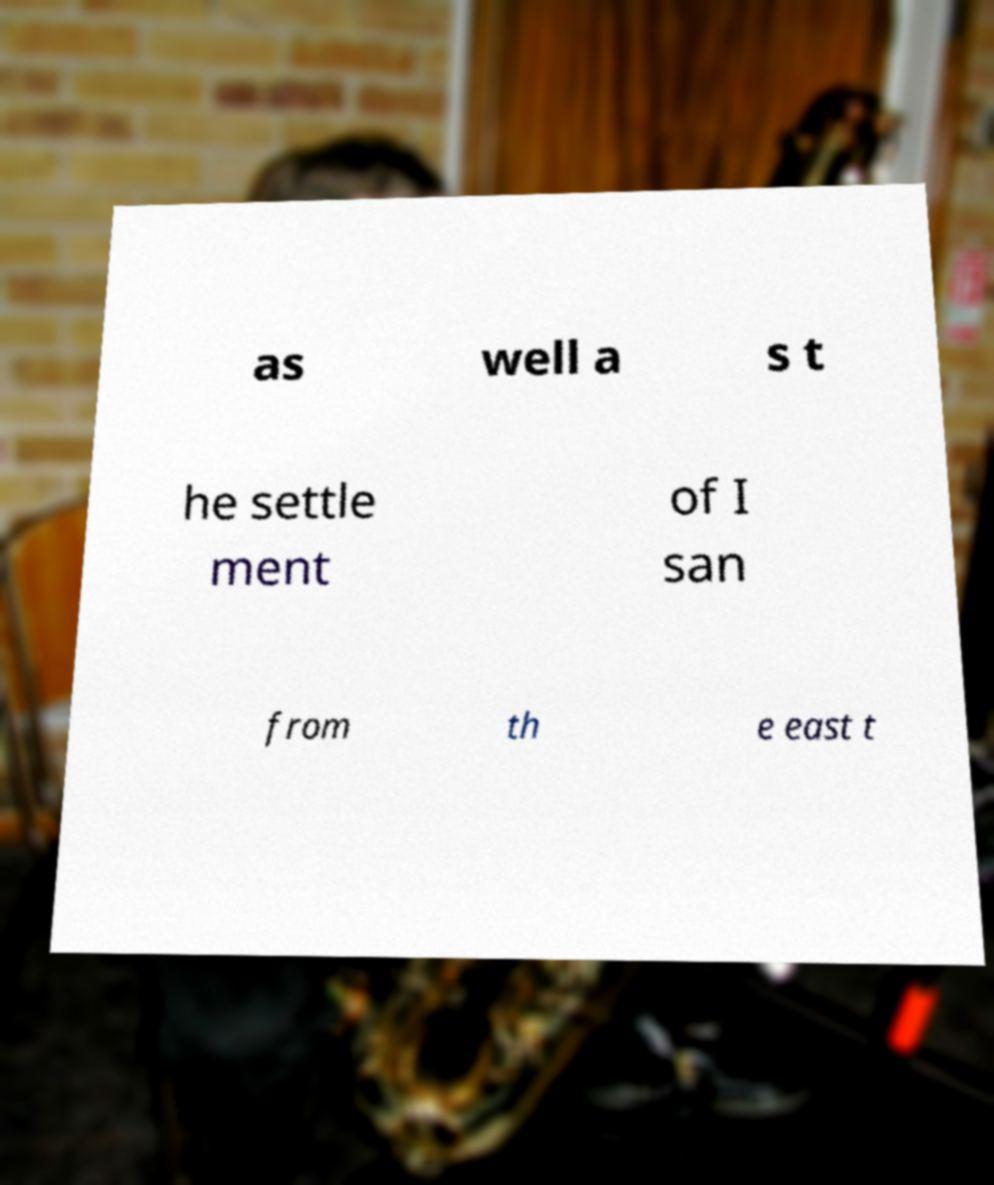Can you accurately transcribe the text from the provided image for me? as well a s t he settle ment of I san from th e east t 